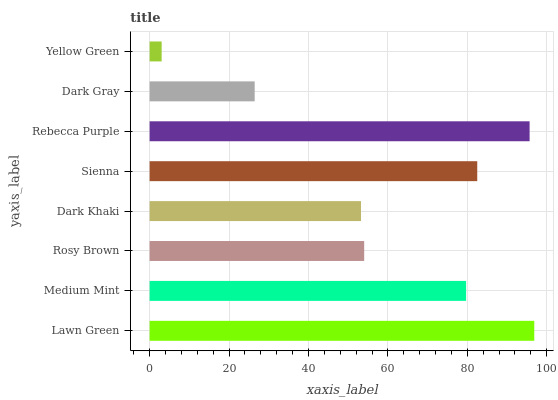Is Yellow Green the minimum?
Answer yes or no. Yes. Is Lawn Green the maximum?
Answer yes or no. Yes. Is Medium Mint the minimum?
Answer yes or no. No. Is Medium Mint the maximum?
Answer yes or no. No. Is Lawn Green greater than Medium Mint?
Answer yes or no. Yes. Is Medium Mint less than Lawn Green?
Answer yes or no. Yes. Is Medium Mint greater than Lawn Green?
Answer yes or no. No. Is Lawn Green less than Medium Mint?
Answer yes or no. No. Is Medium Mint the high median?
Answer yes or no. Yes. Is Rosy Brown the low median?
Answer yes or no. Yes. Is Sienna the high median?
Answer yes or no. No. Is Medium Mint the low median?
Answer yes or no. No. 